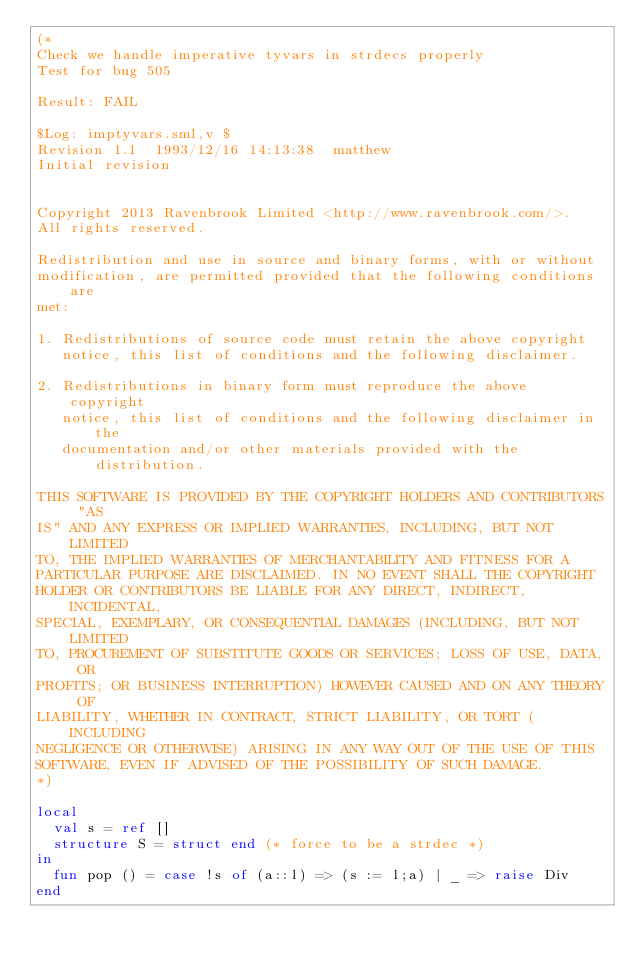<code> <loc_0><loc_0><loc_500><loc_500><_SML_>(*
Check we handle imperative tyvars in strdecs properly
Test for bug 505

Result: FAIL

$Log: imptyvars.sml,v $
Revision 1.1  1993/12/16 14:13:38  matthew
Initial revision


Copyright 2013 Ravenbrook Limited <http://www.ravenbrook.com/>.
All rights reserved.

Redistribution and use in source and binary forms, with or without
modification, are permitted provided that the following conditions are
met:

1. Redistributions of source code must retain the above copyright
   notice, this list of conditions and the following disclaimer.

2. Redistributions in binary form must reproduce the above copyright
   notice, this list of conditions and the following disclaimer in the
   documentation and/or other materials provided with the distribution.

THIS SOFTWARE IS PROVIDED BY THE COPYRIGHT HOLDERS AND CONTRIBUTORS "AS
IS" AND ANY EXPRESS OR IMPLIED WARRANTIES, INCLUDING, BUT NOT LIMITED
TO, THE IMPLIED WARRANTIES OF MERCHANTABILITY AND FITNESS FOR A
PARTICULAR PURPOSE ARE DISCLAIMED. IN NO EVENT SHALL THE COPYRIGHT
HOLDER OR CONTRIBUTORS BE LIABLE FOR ANY DIRECT, INDIRECT, INCIDENTAL,
SPECIAL, EXEMPLARY, OR CONSEQUENTIAL DAMAGES (INCLUDING, BUT NOT LIMITED
TO, PROCUREMENT OF SUBSTITUTE GOODS OR SERVICES; LOSS OF USE, DATA, OR
PROFITS; OR BUSINESS INTERRUPTION) HOWEVER CAUSED AND ON ANY THEORY OF
LIABILITY, WHETHER IN CONTRACT, STRICT LIABILITY, OR TORT (INCLUDING
NEGLIGENCE OR OTHERWISE) ARISING IN ANY WAY OUT OF THE USE OF THIS
SOFTWARE, EVEN IF ADVISED OF THE POSSIBILITY OF SUCH DAMAGE.
*)

local
  val s = ref []
  structure S = struct end (* force to be a strdec *)
in
  fun pop () = case !s of (a::l) => (s := l;a) | _ => raise Div
end

  
</code> 